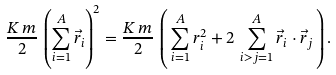<formula> <loc_0><loc_0><loc_500><loc_500>\frac { K \, m } { 2 } \, \left ( \sum _ { i = 1 } ^ { A } \vec { r } _ { i } \right ) ^ { 2 } = \frac { K \, m } { 2 } \, \left ( \, \sum _ { i = 1 } ^ { A } r _ { i } ^ { 2 } + 2 \, \sum _ { i > j = 1 } ^ { A } \vec { r } _ { i } \cdot \vec { r } _ { j } \, \right ) .</formula> 